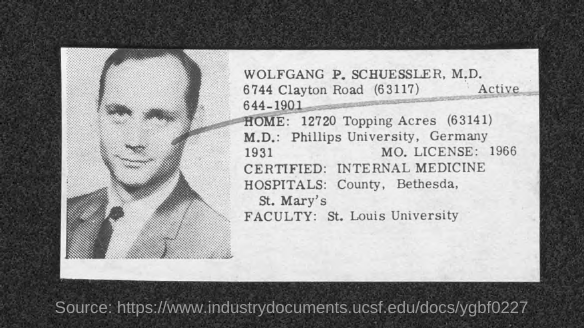Indicate a few pertinent items in this graphic. Wolfgang P. Schuessler, M.D. is a faculty member at St. Louis University. What is your license number? It is 1966... Wolfgang P. Schuessler, M.D. is certified in Internal Medicine. 